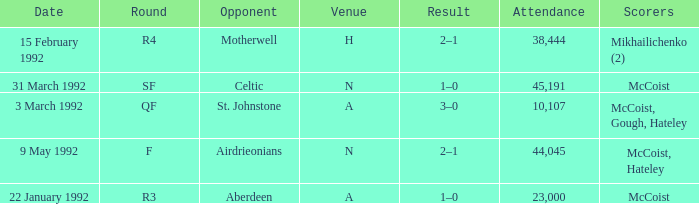In which venue was round F? N. Can you parse all the data within this table? {'header': ['Date', 'Round', 'Opponent', 'Venue', 'Result', 'Attendance', 'Scorers'], 'rows': [['15 February 1992', 'R4', 'Motherwell', 'H', '2–1', '38,444', 'Mikhailichenko (2)'], ['31 March 1992', 'SF', 'Celtic', 'N', '1–0', '45,191', 'McCoist'], ['3 March 1992', 'QF', 'St. Johnstone', 'A', '3–0', '10,107', 'McCoist, Gough, Hateley'], ['9 May 1992', 'F', 'Airdrieonians', 'N', '2–1', '44,045', 'McCoist, Hateley'], ['22 January 1992', 'R3', 'Aberdeen', 'A', '1–0', '23,000', 'McCoist']]} 